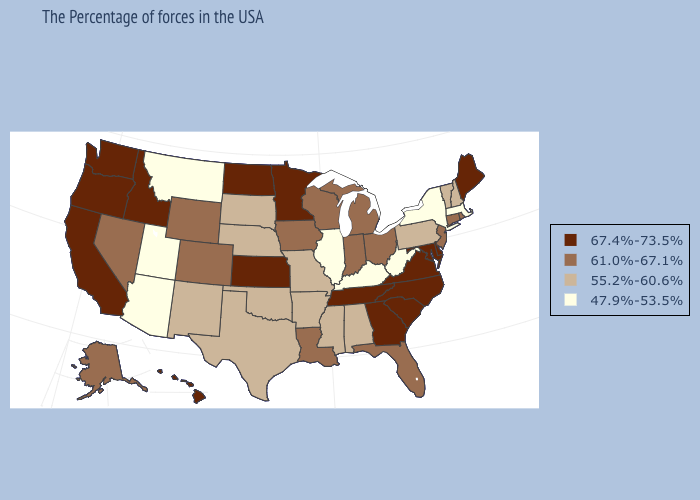Name the states that have a value in the range 67.4%-73.5%?
Short answer required. Maine, Delaware, Maryland, Virginia, North Carolina, South Carolina, Georgia, Tennessee, Minnesota, Kansas, North Dakota, Idaho, California, Washington, Oregon, Hawaii. Is the legend a continuous bar?
Answer briefly. No. Which states have the lowest value in the South?
Be succinct. West Virginia, Kentucky. What is the lowest value in the South?
Keep it brief. 47.9%-53.5%. Does the map have missing data?
Concise answer only. No. What is the value of New Mexico?
Be succinct. 55.2%-60.6%. Name the states that have a value in the range 61.0%-67.1%?
Give a very brief answer. Rhode Island, Connecticut, New Jersey, Ohio, Florida, Michigan, Indiana, Wisconsin, Louisiana, Iowa, Wyoming, Colorado, Nevada, Alaska. What is the value of North Dakota?
Answer briefly. 67.4%-73.5%. What is the value of Ohio?
Concise answer only. 61.0%-67.1%. What is the highest value in the South ?
Concise answer only. 67.4%-73.5%. Does the map have missing data?
Quick response, please. No. Which states have the highest value in the USA?
Write a very short answer. Maine, Delaware, Maryland, Virginia, North Carolina, South Carolina, Georgia, Tennessee, Minnesota, Kansas, North Dakota, Idaho, California, Washington, Oregon, Hawaii. Among the states that border New Hampshire , which have the lowest value?
Write a very short answer. Massachusetts. What is the highest value in the USA?
Be succinct. 67.4%-73.5%. 